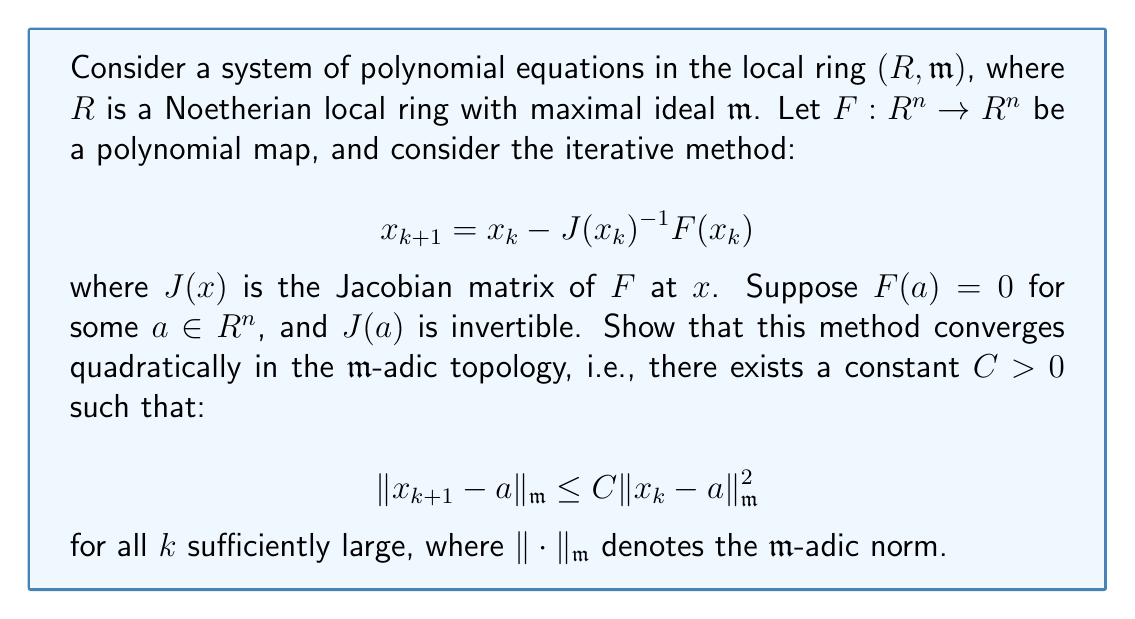Help me with this question. To prove this, we'll use a local algebra approach, analogous to cultivating a garden where we focus on a small patch (our local ring) and observe how our plants (iterations) grow closer together.

1) First, let's expand $F(x)$ around $a$ using Taylor's theorem in the local ring setting:

   $$F(x) = F(a) + J(a)(x-a) + R(x-a)$$

   where $R(x-a)$ is the remainder term satisfying $\|R(x-a)\|_{\mathfrak{m}} = o(\|x-a\|_{\mathfrak{m}})$.

2) Since $F(a) = 0$, we can simplify:

   $$F(x) = J(a)(x-a) + R(x-a)$$

3) Now, let's look at the iteration step:

   $$x_{k+1} - a = x_k - a - J(x_k)^{-1}F(x_k)$$

4) Substitute the Taylor expansion:

   $$x_{k+1} - a = x_k - a - J(x_k)^{-1}[J(a)(x_k-a) + R(x_k-a)]$$

5) Add and subtract $J(a)^{-1}$ inside the brackets:

   $$x_{k+1} - a = x_k - a - [J(x_k)^{-1} - J(a)^{-1} + J(a)^{-1}][J(a)(x_k-a) + R(x_k-a)]$$

6) Simplify:

   $$x_{k+1} - a = [I - J(a)^{-1}J(a)](x_k-a) - J(a)^{-1}R(x_k-a) - [J(x_k)^{-1} - J(a)^{-1}][J(a)(x_k-a) + R(x_k-a)]$$

7) The first term vanishes, leaving:

   $$x_{k+1} - a = - J(a)^{-1}R(x_k-a) - [J(x_k)^{-1} - J(a)^{-1}][J(a)(x_k-a) + R(x_k-a)]$$

8) Now, we can bound each term:
   - $\|J(a)^{-1}R(x_k-a)\|_{\mathfrak{m}} \leq C_1\|x_k-a\|_{\mathfrak{m}}^2$ for some $C_1 > 0$
   - $\|J(x_k)^{-1} - J(a)^{-1}\|_{\mathfrak{m}} \leq C_2\|x_k-a\|_{\mathfrak{m}}$ for some $C_2 > 0$
   - $\|J(a)(x_k-a) + R(x_k-a)\|_{\mathfrak{m}} \leq C_3\|x_k-a\|_{\mathfrak{m}}$ for some $C_3 > 0$

9) Combining these bounds:

   $$\|x_{k+1} - a\|_{\mathfrak{m}} \leq C_1\|x_k-a\|_{\mathfrak{m}}^2 + C_2C_3\|x_k-a\|_{\mathfrak{m}}^2 = C\|x_k-a\|_{\mathfrak{m}}^2$$

   where $C = C_1 + C_2C_3$.

This proves the quadratic convergence in the $\mathfrak{m}$-adic topology.
Answer: The iterative method converges quadratically in the $\mathfrak{m}$-adic topology, with the inequality:

$$\|x_{k+1} - a\|_{\mathfrak{m}} \leq C\|x_k - a\|_{\mathfrak{m}}^2$$

holding for some constant $C > 0$ and for all $k$ sufficiently large. 